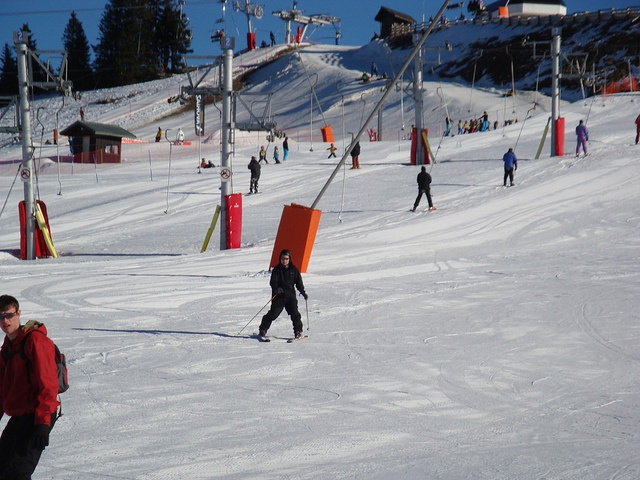Describe the objects in this image and their specific colors. I can see people in blue, black, brown, and maroon tones, people in blue, black, darkgray, maroon, and lightgray tones, people in blue, darkgray, gray, navy, and black tones, backpack in blue, black, gray, darkgray, and brown tones, and people in blue, black, navy, darkgray, and gray tones in this image. 